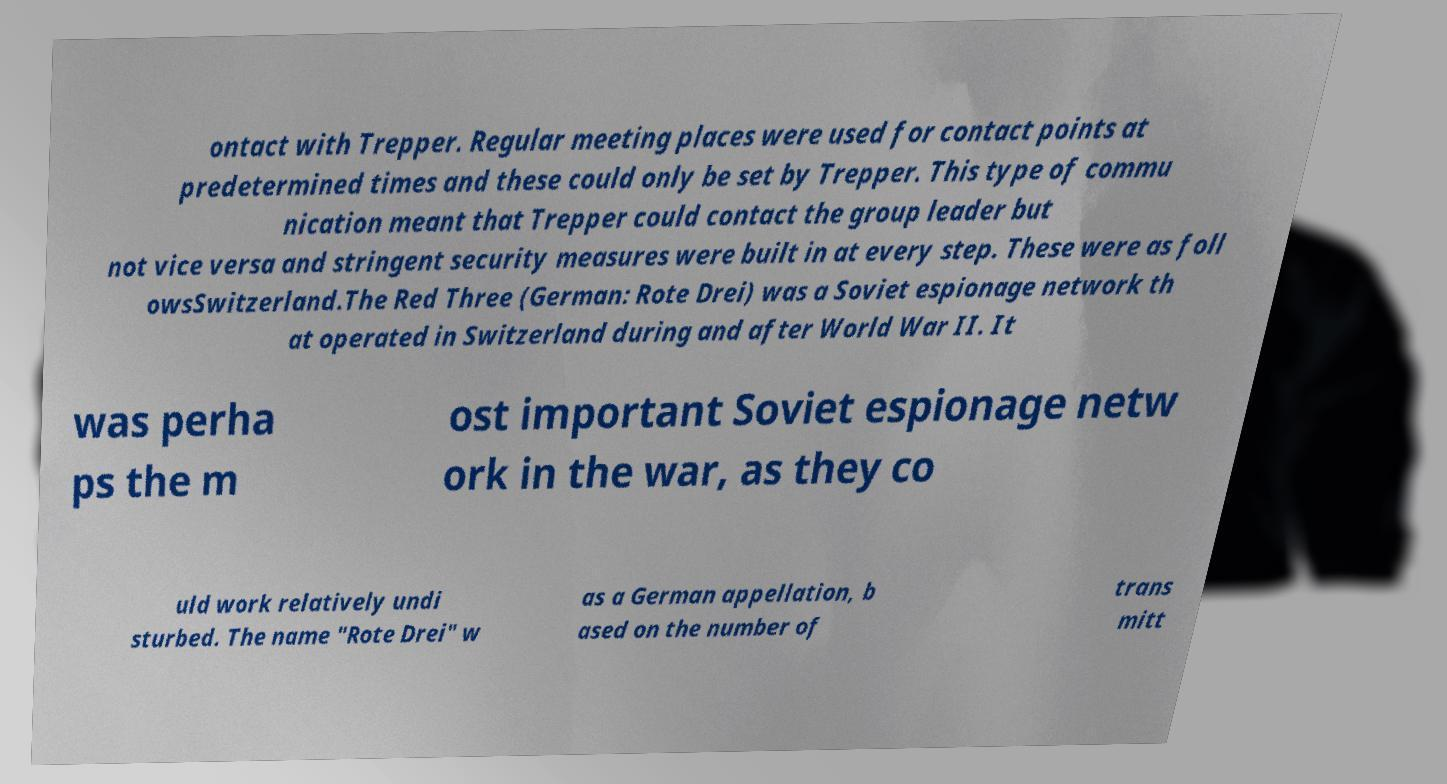Please identify and transcribe the text found in this image. ontact with Trepper. Regular meeting places were used for contact points at predetermined times and these could only be set by Trepper. This type of commu nication meant that Trepper could contact the group leader but not vice versa and stringent security measures were built in at every step. These were as foll owsSwitzerland.The Red Three (German: Rote Drei) was a Soviet espionage network th at operated in Switzerland during and after World War II. It was perha ps the m ost important Soviet espionage netw ork in the war, as they co uld work relatively undi sturbed. The name "Rote Drei" w as a German appellation, b ased on the number of trans mitt 